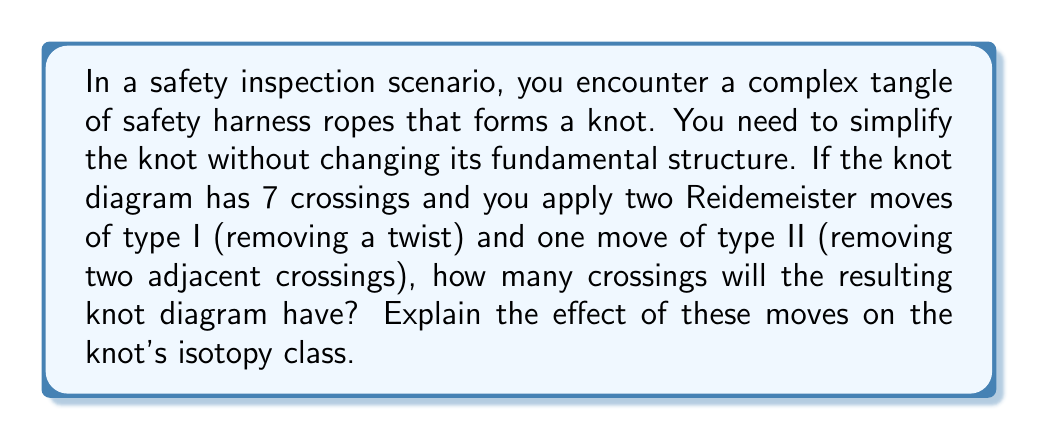Show me your answer to this math problem. Let's approach this step-by-step:

1) Initial state: The knot diagram has 7 crossings.

2) Reidemeister moves:
   - Type I move (twice): Each Type I move removes one crossing.
   - Type II move (once): A Type II move removes two crossings.

3) Calculation:
   $$ 7 - (1 + 1 + 2) = 7 - 4 = 3 $$

4) Effect on isotopy class:
   Reidemeister moves do not change the isotopy class of a knot. They are ambient isotopies that preserve the knot type. This means:

   $$ [K] = [K'] $$

   where $[K]$ is the isotopy class of the original knot and $[K']$ is the isotopy class of the knot after applying the Reidemeister moves.

5) Explanation of isotopy preservation:
   - Type I move: Removes or adds a twist, which doesn't affect the knot's fundamental structure.
   - Type II move: Separates or combines two strands running in opposite directions, also preserving the knot type.

6) In the context of safety inspection:
   These moves allow you to simplify the visual representation of the tangled ropes without altering their fundamental interconnection, ensuring that your analysis of the safety harness configuration remains valid.
Answer: 3 crossings; isotopy class unchanged 